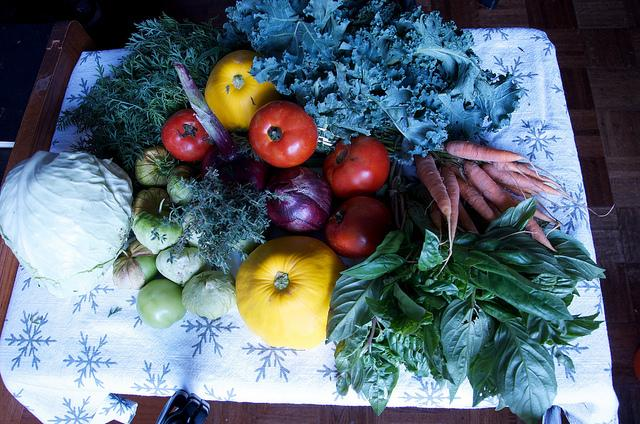What is the large vegetable on the far left?

Choices:
A) yam
B) cabbage
C) lettuce
D) pumpkin cabbage 